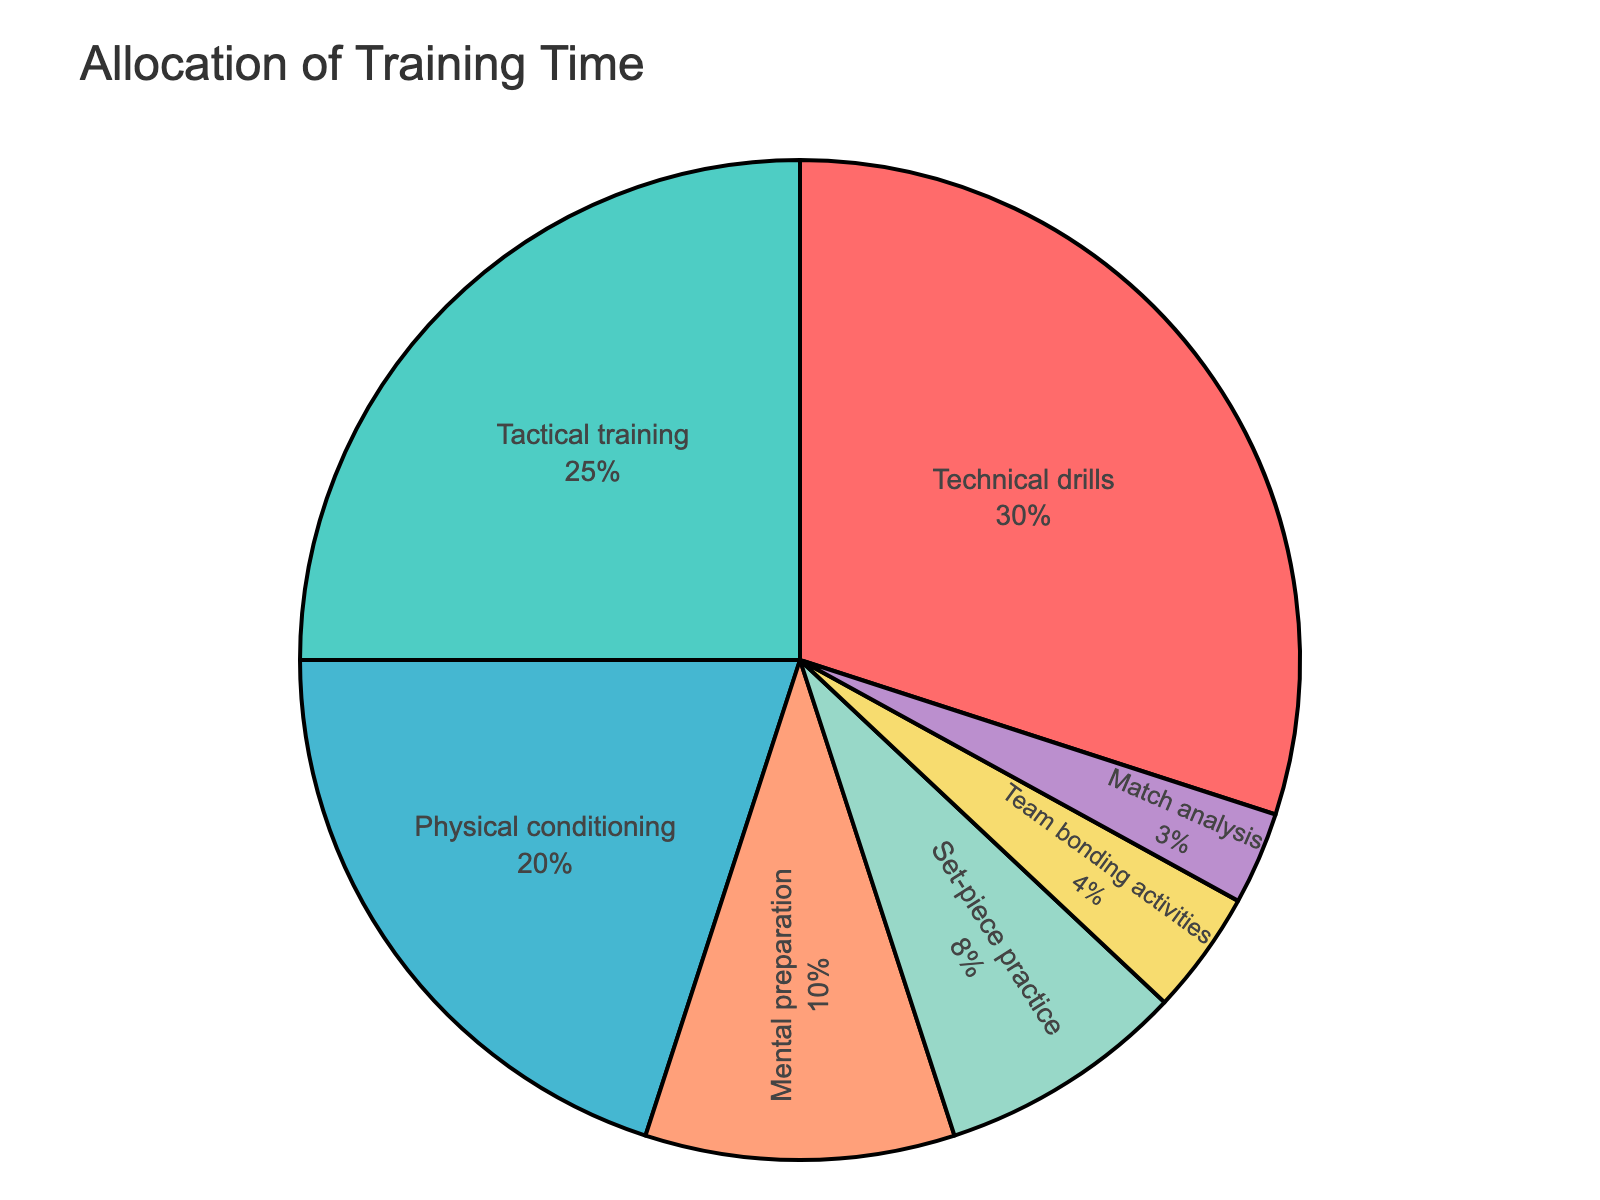Which skill is allocated the highest percentage of training time? The pie chart indicates the distribution of training time across different skills. The largest segment represents "Technical drills". This segment covers 30% of the total training time.
Answer: Technical drills How much more time is allocated to Tactical training compared to Set-piece practice? To determine the difference, identify the percentage for both skills: Tactical training (25%) and Set-piece practice (8%). Then subtract the smaller percentage from the larger one: 25% - 8% = 17%.
Answer: 17% What is the combined percentage of time allocated to Physical conditioning and Mental preparation? First, identify the percentages for both: Physical conditioning (20%) and Mental preparation (10%). Then, sum them up: 20% + 10% = 30%.
Answer: 30% Which skill is allocated the least training time? The smallest segment in the pie chart represents the skill "Match analysis", accounting for 3% of the total training time.
Answer: Match analysis How does the percentage of Team bonding activities compare to Match analysis? By comparing the percentages directly from the chart, Team bonding activities (4%) is slightly higher than Match analysis (3%).
Answer: Team bonding activities is higher Which skill category has a percentage closest to the average training time allocation across all categories? First, calculate the average by summing the percentages and dividing by the number of skills: (30% + 25% + 20% + 10% + 8% + 4% + 3%) / 7 = 100% / 7 ≈ 14.29%. The value closest to this average is "Mental preparation" at 10%.
Answer: Mental preparation Rank the top three skills based on their allocated training time. Assess the percentages for each skill and rank them in descending order: Technical drills (30%), Tactical training (25%), Physical conditioning (20%).
Answer: Technical drills, Tactical training, Physical conditioning Which two skills combined take up as much time as Technical drills? First, the intended combined percentage is that of Technical drills (30%). The sum of Physical conditioning (20%) and Mental preparation (10%) equals 20% + 10% = 30%.
Answer: Physical conditioning and Mental preparation By what percentage does Tactical training exceed Mental preparation? Identify the percentages for both: Tactical training (25%) and Mental preparation (10%). Then, calculate the difference: 25% - 10% = 15%.
Answer: 15% 